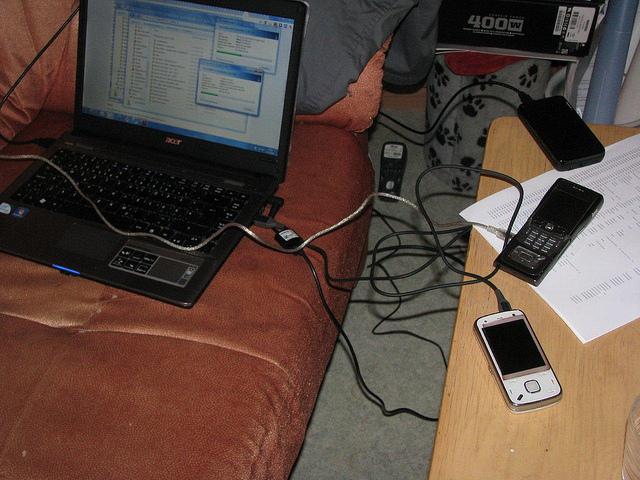What is the remote for?
Be succinct. Tv. Are the object placed there randomly or arranged?
Answer briefly. Randomly. What color is the cell phone?
Quick response, please. White. How many electronics are currently charging?
Short answer required. 4. Where is the phone?
Answer briefly. On desk. Are these electronic devices dated?
Give a very brief answer. Yes. Is the laptop synced to the phones?
Quick response, please. Yes. What brand is the phone?
Keep it brief. Apple. What brand of phone is pictured?
Answer briefly. Apple. 